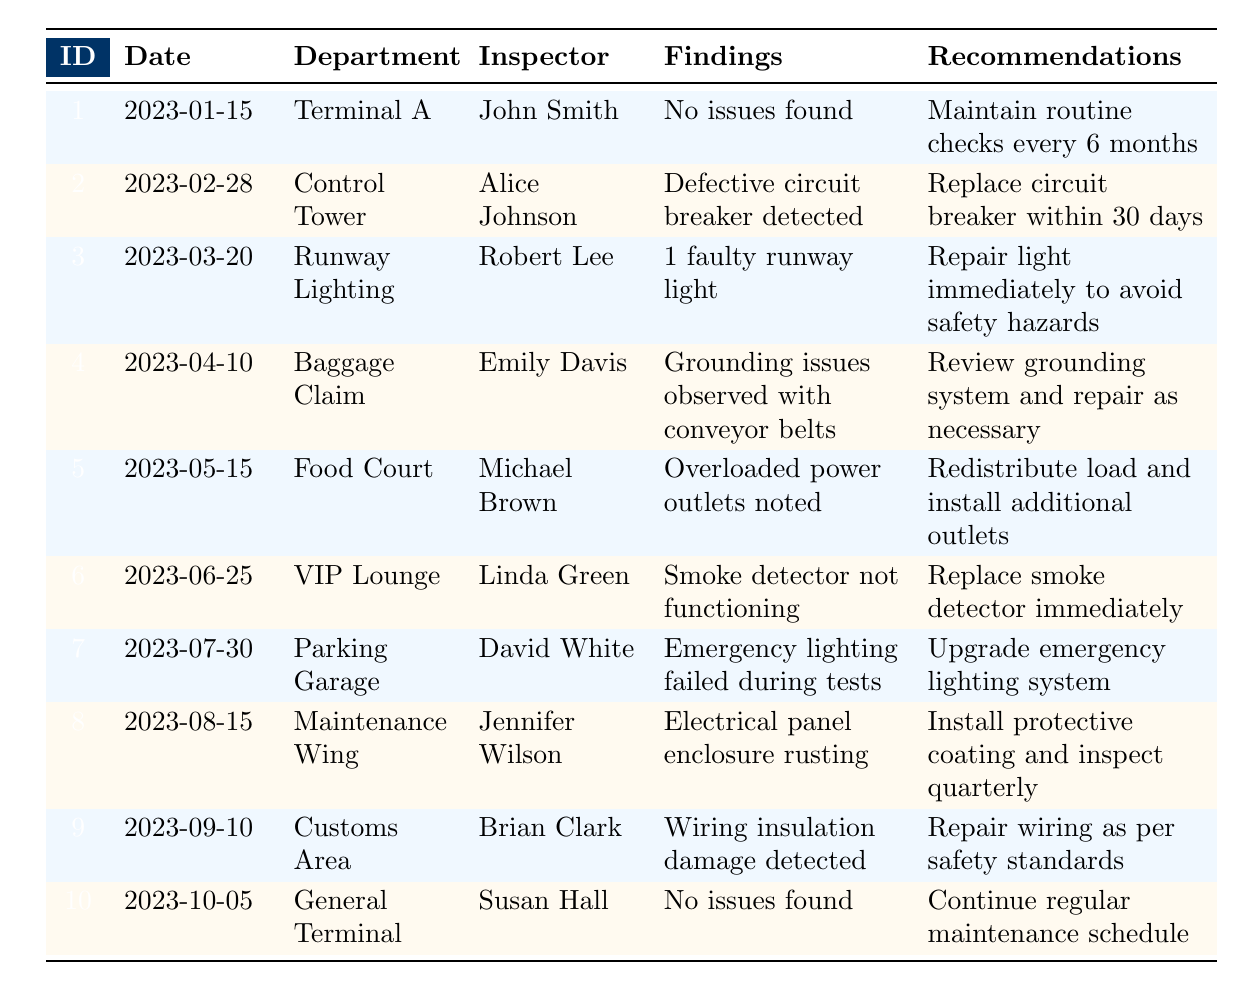What department had no issues found during the electrical safety inspections? The table shows that "Terminal A" and "General Terminal" had "No issues found" in their findings. By filtering the table for this specific finding, we see that these two departments reported no issues.
Answer: Terminal A, General Terminal Who conducted the inspection in the Food Court department? According to the table, the inspection for the Food Court was conducted by "Michael Brown." This information is directly available in the corresponding row for the Food Court.
Answer: Michael Brown What is the recommendation given for the inspection conducted on March 20, 2023? The inspection conducted on this date was for "Runway Lighting" and the recommendation provided was "Repair light immediately to avoid safety hazards." This can be found in the respective row of the table.
Answer: Repair light immediately to avoid safety hazards How many departments reported issues with their electrical systems? By reviewing the table, we count the departments that did not have "No issues found" in their findings. These departments are Control Tower, Runway Lighting, Baggage Claim, Food Court, VIP Lounge, Parking Garage, Maintenance Wing, and Customs Area. This totals to 8 departments reporting issues.
Answer: 8 Was there a recommendation for upgrading any systems? "Yes," the table lists a recommendation to "Upgrade emergency lighting system" for the Parking Garage. This corresponds to the findings of an emergency lighting failure during tests, indicating a need for improvement.
Answer: Yes What findings were made in the VIP Lounge, and what was recommended? The VIP Lounge inspection found that the "Smoke detector not functioning." The recommendation given was to "Replace smoke detector immediately." This detailed information can be easily identified in the table under the pertinent row.
Answer: Smoke detector not functioning; Replace smoke detector immediately Which inspection had the earliest date and what were the findings? The earliest date listed in the inspections is "2023-01-15," corresponding to the inspection in "Terminal A," where "No issues found." This is verifiable by checking the date column sequentially.
Answer: Terminal A, No issues found What steps should be taken for the grounding issues found in the Baggage Claim? The recommendation following the findings for the Baggage Claim inspection, which noted "Grounding issues observed with conveyor belts," is to "Review grounding system and repair as necessary." The needed actions are clearly provided in this row of the table.
Answer: Review grounding system and repair as necessary 